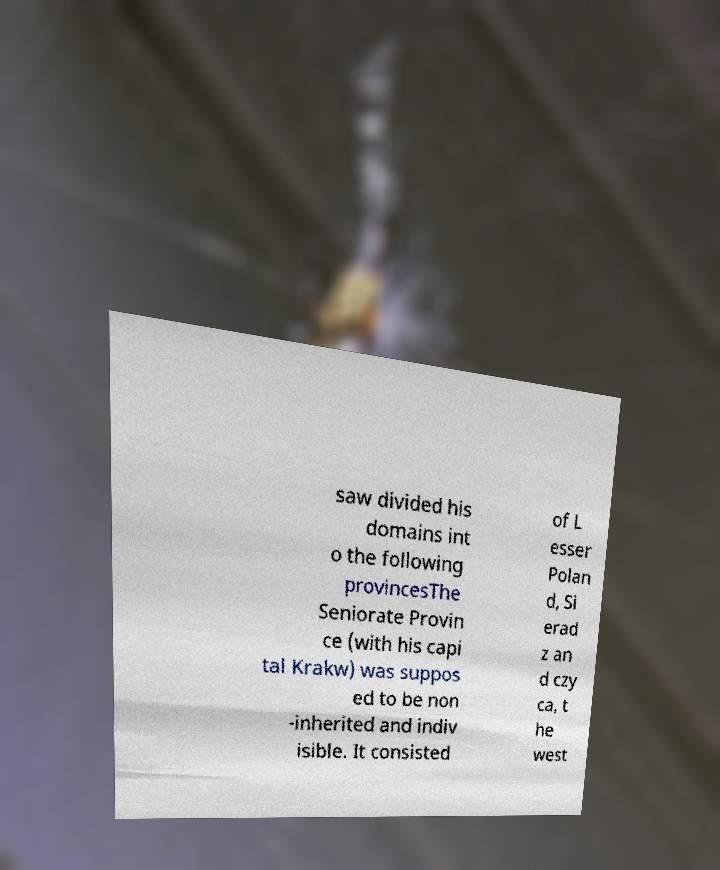Please read and relay the text visible in this image. What does it say? saw divided his domains int o the following provincesThe Seniorate Provin ce (with his capi tal Krakw) was suppos ed to be non -inherited and indiv isible. It consisted of L esser Polan d, Si erad z an d czy ca, t he west 